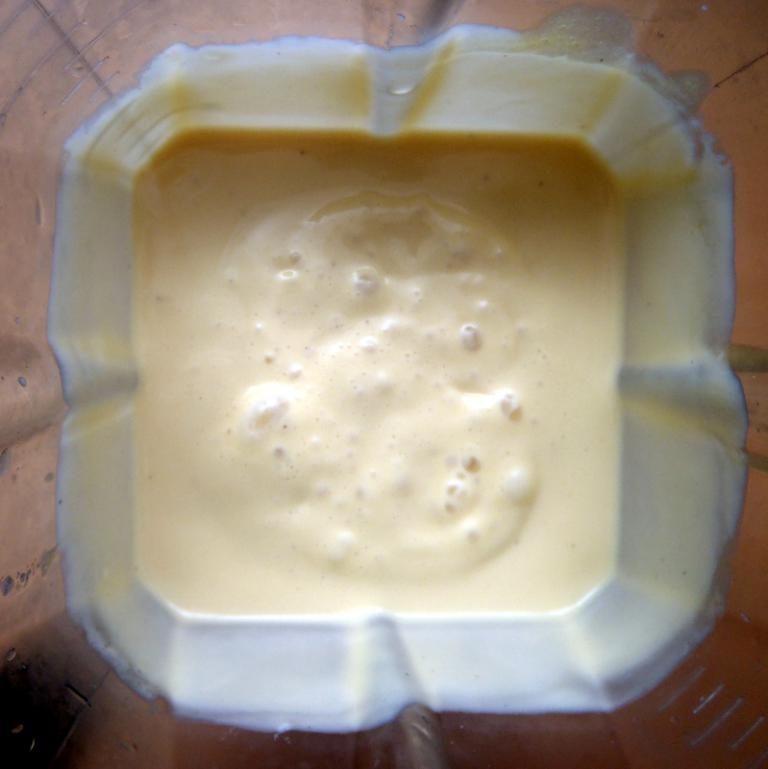What is contained in the tumbler that is visible in the image? There is a smoothie in a tumbler in the image. Who is the representative of the smoothie in the image? There is no representative of the smoothie in the image, as it is an inanimate object. Is there a quill or feather present in the image? No, there is no quill or feather present in the image. 